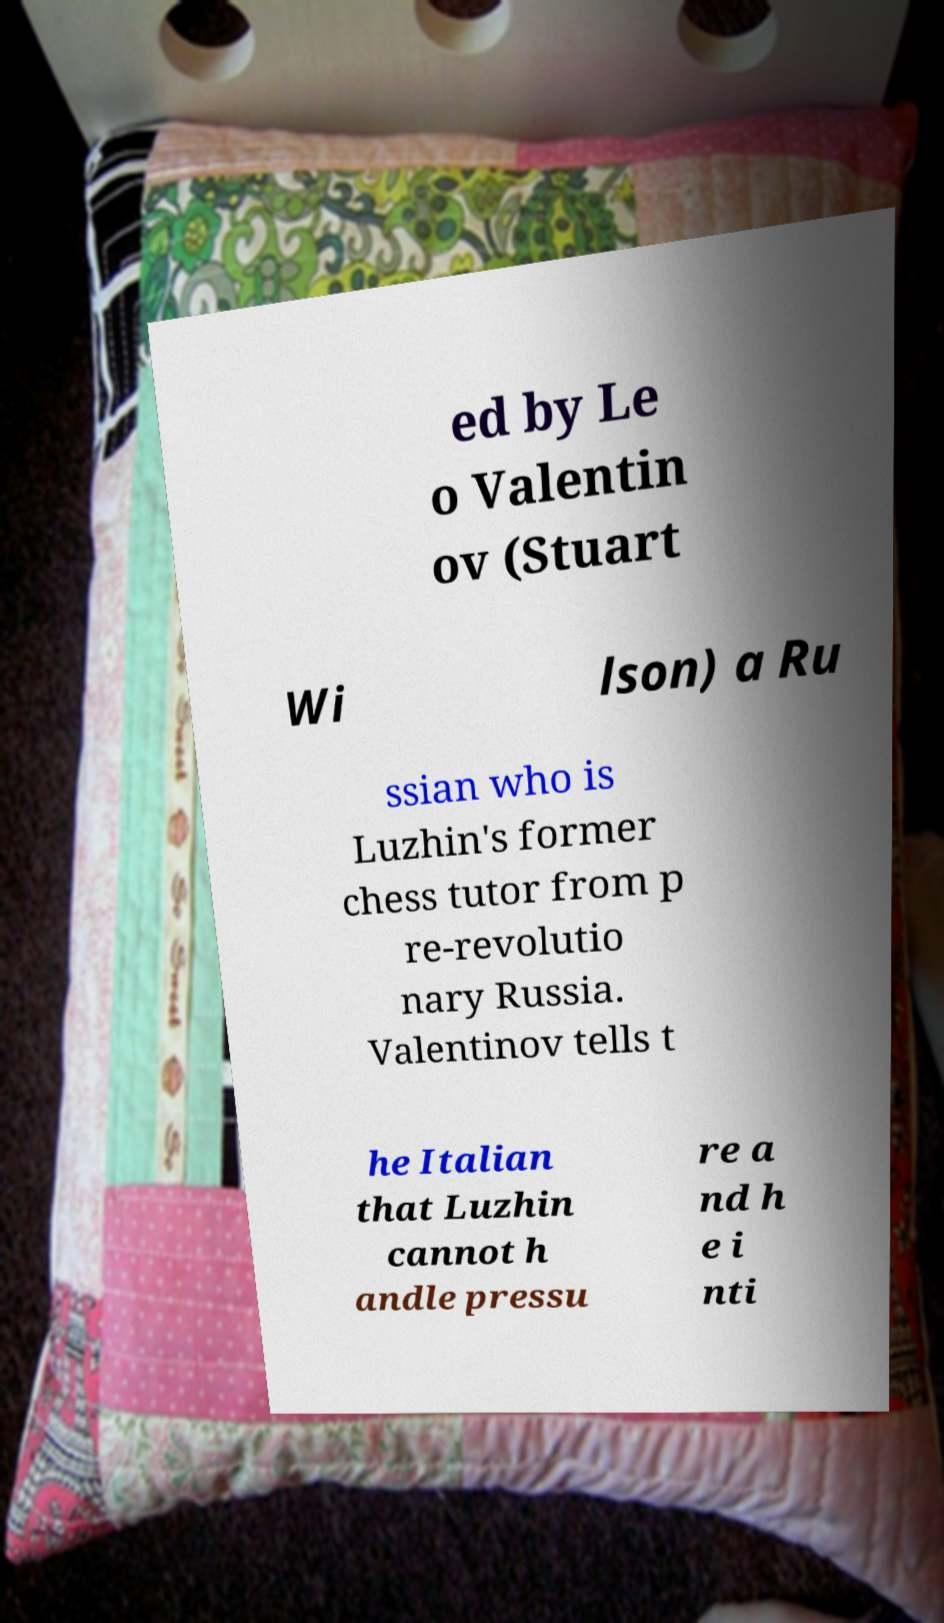I need the written content from this picture converted into text. Can you do that? ed by Le o Valentin ov (Stuart Wi lson) a Ru ssian who is Luzhin's former chess tutor from p re-revolutio nary Russia. Valentinov tells t he Italian that Luzhin cannot h andle pressu re a nd h e i nti 